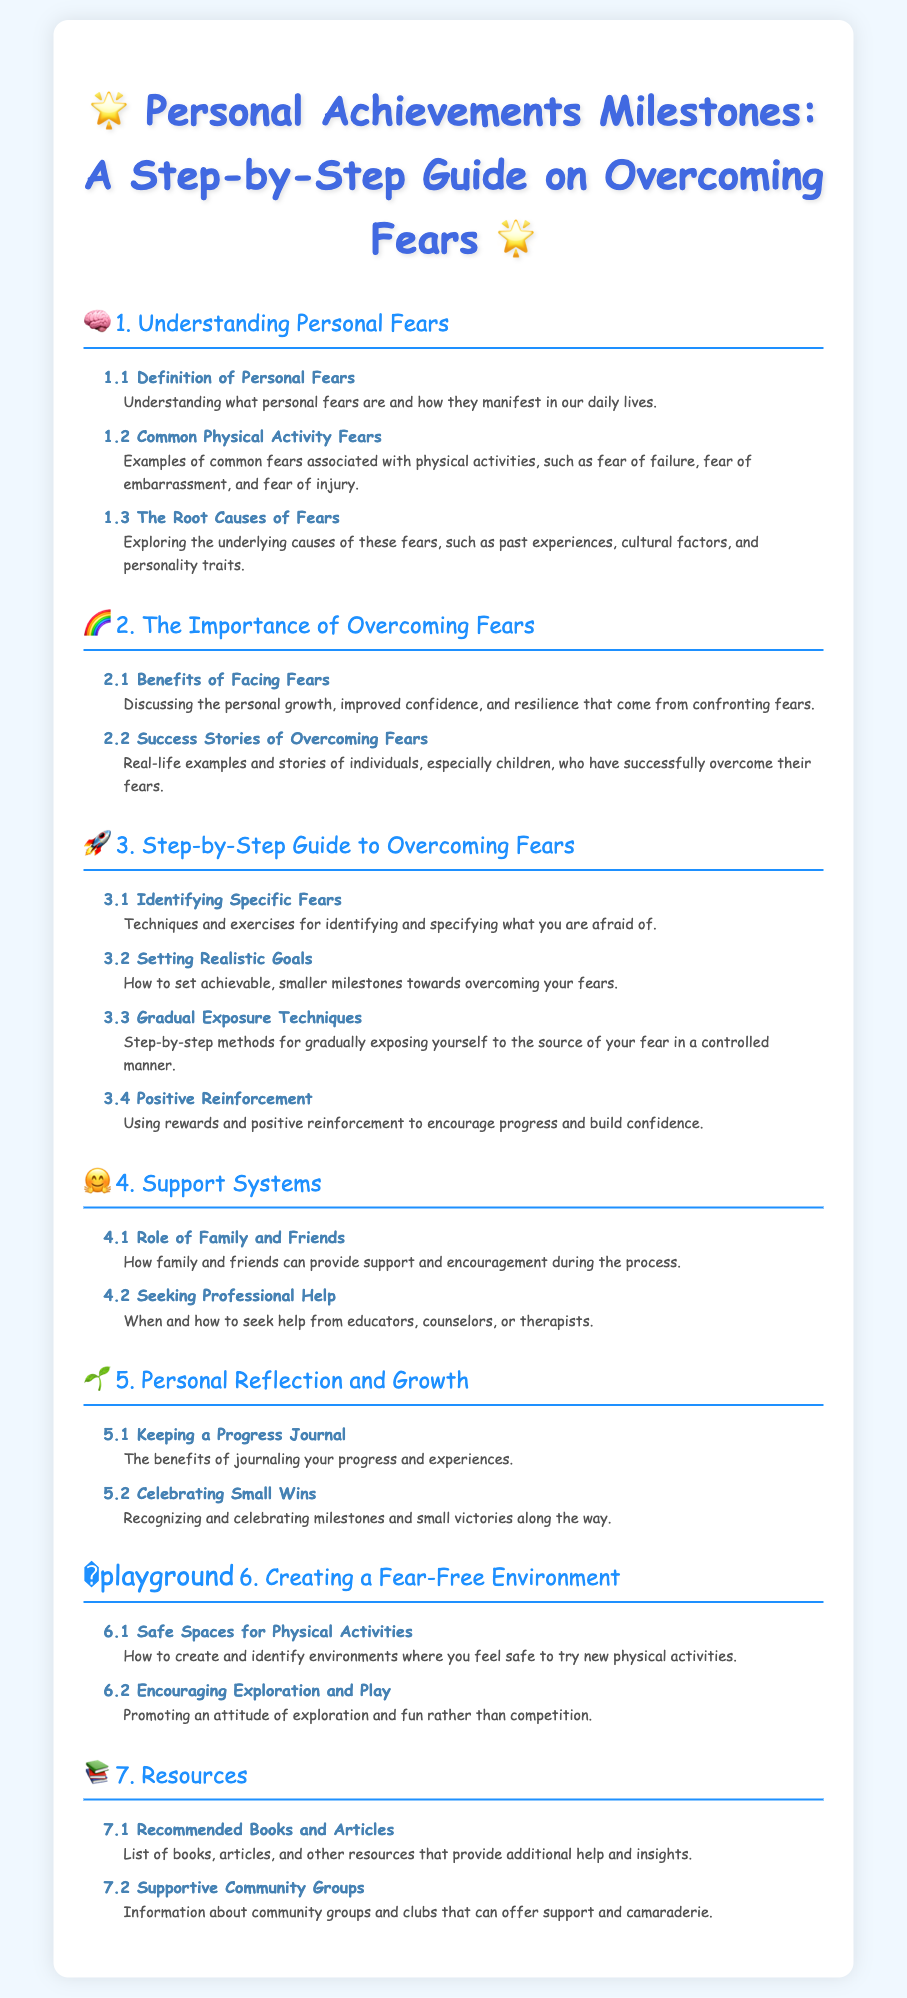What is the title of the document? The title is clearly stated at the beginning of the document and is "Personal Achievements Milestones: A Step-by-Step Guide on Overcoming Fears."
Answer: Personal Achievements Milestones: A Step-by-Step Guide on Overcoming Fears What section discusses the benefits of facing fears? The section that covers benefits is clearly labeled as 2.1, which addresses the advantages of confronting one's fears.
Answer: 2.1 Benefits of Facing Fears How many subsections are in the third section? The third section includes four subsections, each focusing on different aspects of overcoming fears.
Answer: 4 What is the main topic of section 4? Section 4 focuses on the support systems that can aid individuals in overcoming their fears.
Answer: Support Systems What is one qualitative benefit of keeping a progress journal? The document states that journaling has benefits, including tracking progress and reflecting on experiences.
Answer: Keeping a Progress Journal Which subsection deals with the role of family and friends? The subsection titled "Role of Family and Friends" falls under section 4, which discusses support systems.
Answer: Role of Family and Friends What is the purpose of gradual exposure techniques? Gradual exposure techniques aim to help individuals slowly confront their fears in a controlled manner.
Answer: Gradual Exposure Techniques What is emphasized in section 6.2? Section 6.2 emphasizes promoting exploration and play rather than competition during physical activities.
Answer: Encouraging Exploration and Play 